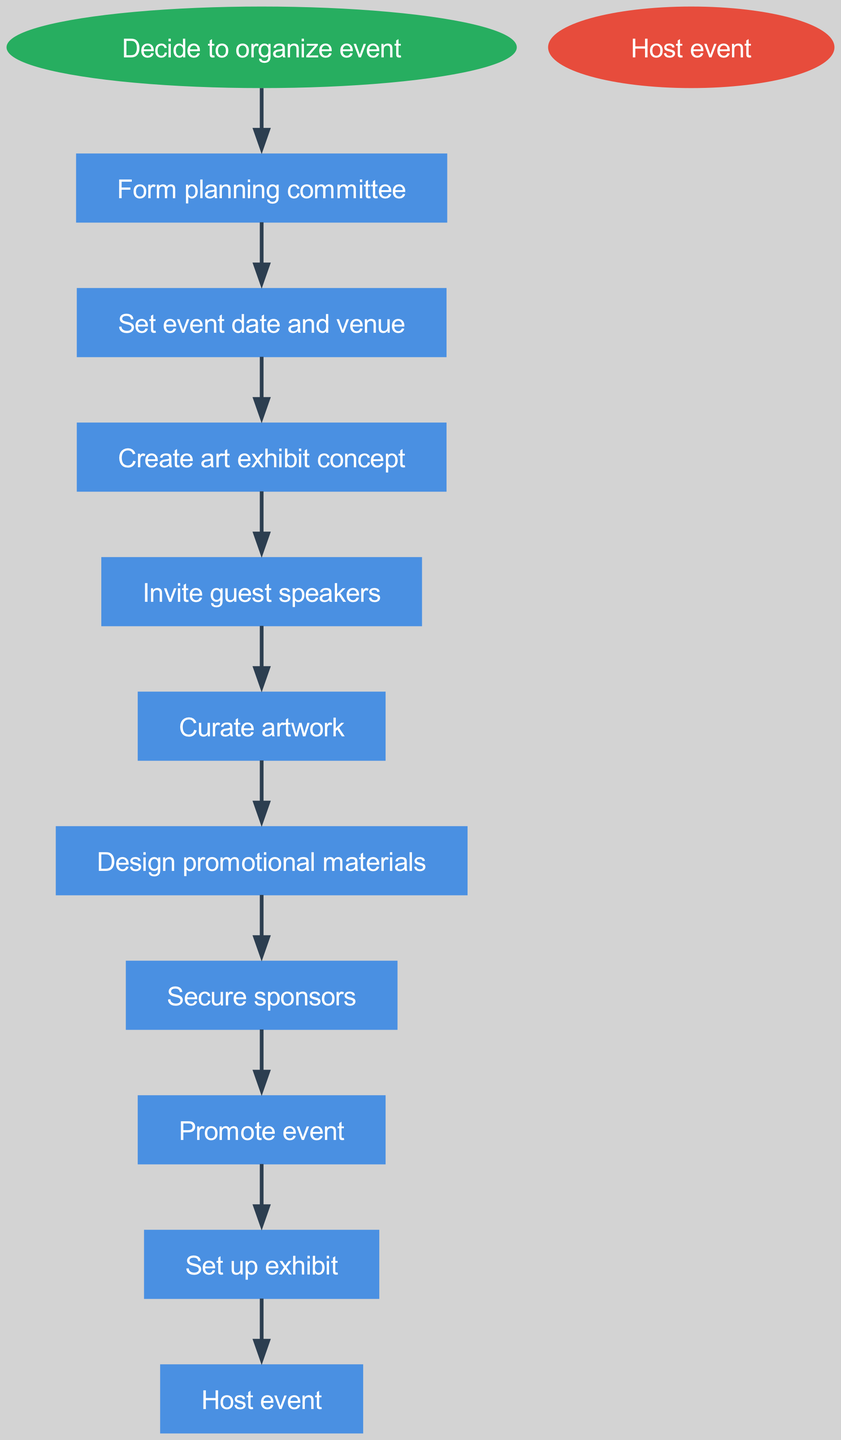What is the first step in the diagram? The first step is represented by the node connected directly to the "start" node. According to the steps, the first action after deciding to organize the event is to "Form planning committee."
Answer: Form planning committee How many steps are there from start to end? The total number of steps can be counted by reviewing the individual connections between nodes, leading from the start to the end. There are 9 distinct steps listed in the diagram.
Answer: 9 What is the last step in the diagram? The last step is shown as the endpoint of the flow chart, which is the node connected to the "end." The final action is to "Host event."
Answer: Host event Which step follows "Curate artwork"? To determine the step that follows "Curate artwork," we look at the edge that leads out from that step node in the diagram. The next step indicated is "Design promotional materials."
Answer: Design promotional materials What does "Set event date and venue" lead to? By tracing the edge coming out of the "Set event date and venue" node, we see that it leads to the subsequent action noted in the diagram, which is "Create art exhibit concept."
Answer: Create art exhibit concept Which step is immediately before "Promote event"? To find the step that comes directly before "Promote event," we check the connection leading to it. The previous step shown in the diagram is "Secure sponsors."
Answer: Secure sponsors How many edges are in the diagram? Each connection between nodes represents an edge in the diagram. By following from the start to the end, we can count a total of 8 edges connecting each step in sequence.
Answer: 8 What is the relationship between "Invite guest speakers" and "Curate artwork"? The relationship can be defined by the sequential connection shown in the diagram. "Invite guest speakers" leads directly to "Curate artwork," indicating that one follows the other in the event organization process.
Answer: Invite guest speakers leads to Curate artwork What color is the start node? The color of the start node is specifically mentioned in the diagram’s attributes. It is colored in a green shade, specifically '#27AE60.'
Answer: Green 